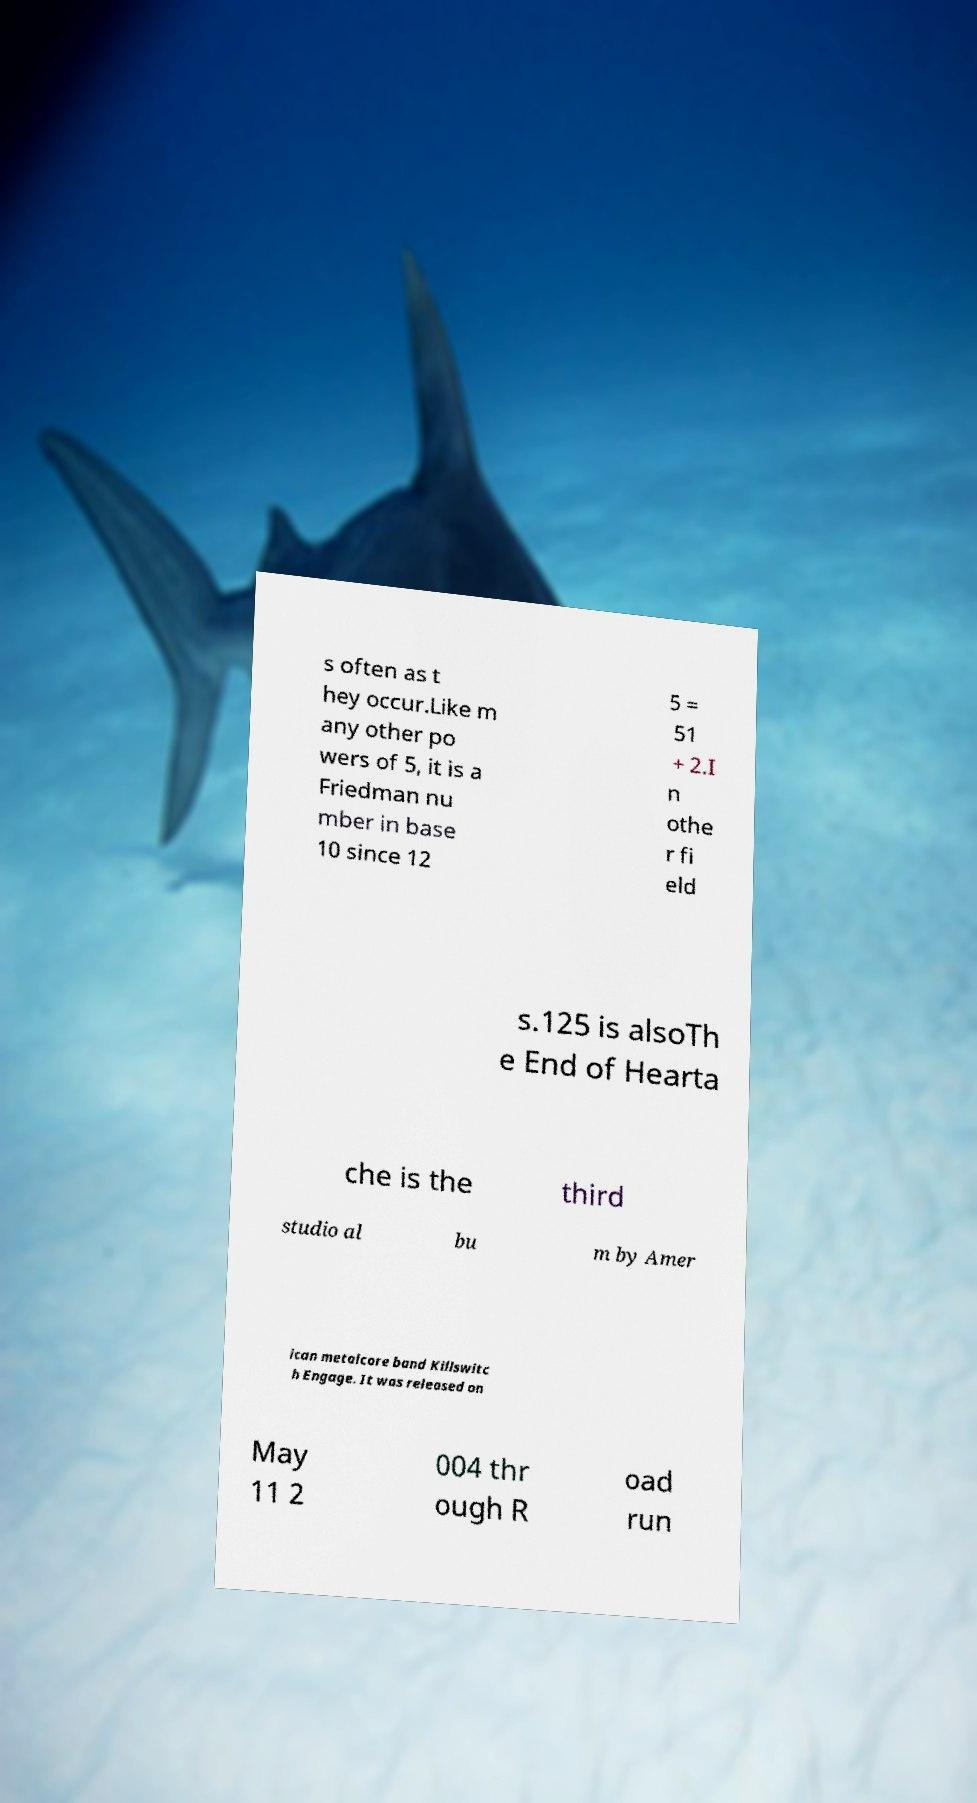Can you read and provide the text displayed in the image?This photo seems to have some interesting text. Can you extract and type it out for me? s often as t hey occur.Like m any other po wers of 5, it is a Friedman nu mber in base 10 since 12 5 = 51 + 2.I n othe r fi eld s.125 is alsoTh e End of Hearta che is the third studio al bu m by Amer ican metalcore band Killswitc h Engage. It was released on May 11 2 004 thr ough R oad run 